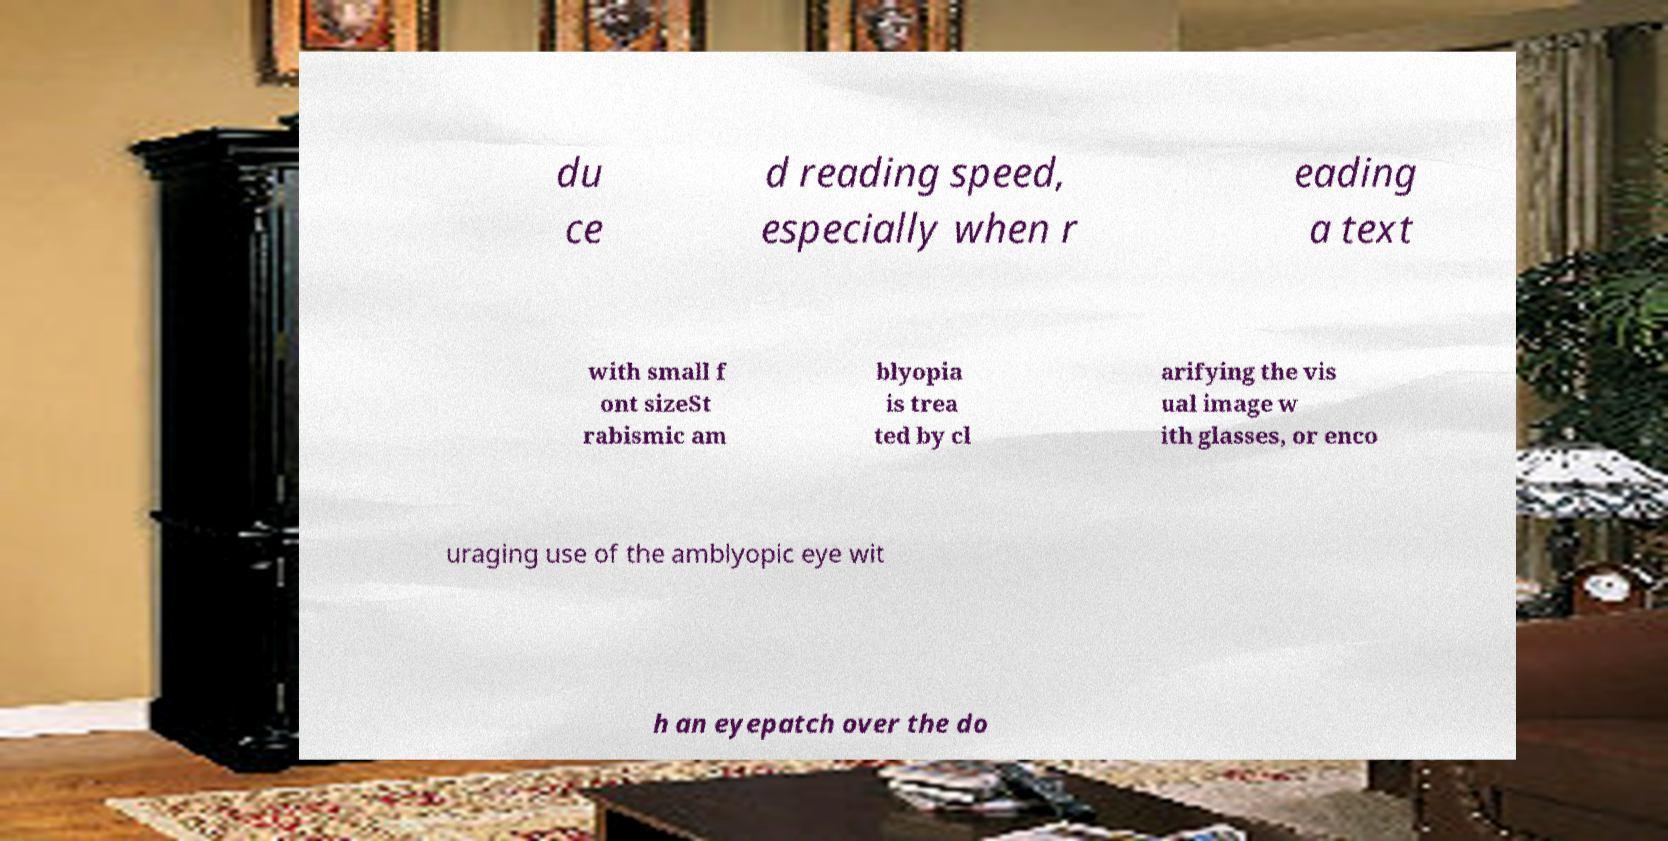Can you accurately transcribe the text from the provided image for me? du ce d reading speed, especially when r eading a text with small f ont sizeSt rabismic am blyopia is trea ted by cl arifying the vis ual image w ith glasses, or enco uraging use of the amblyopic eye wit h an eyepatch over the do 